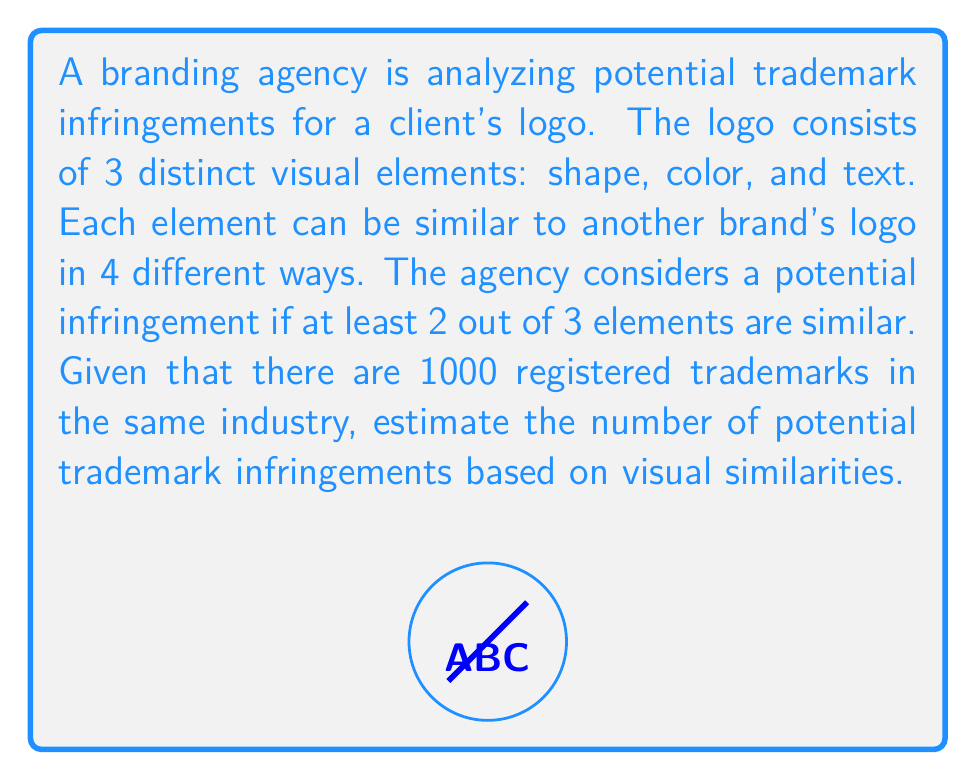Could you help me with this problem? Let's approach this step-by-step:

1) First, we need to calculate the probability of a single element being similar:
   For each element, there are 4 ways it can be similar out of 4 possible ways.
   Probability of similarity for one element = $\frac{4}{4} = 1$

2) Now, we need to calculate the probability of at least 2 out of 3 elements being similar:
   - Probability of all 3 elements being similar: $1 \times 1 \times 1 = 1$
   - Probability of exactly 2 elements being similar: $\binom{3}{2} \times 1 \times 1 \times 0 = 0$
   - Total probability: $1 + 0 = 1$

3) The probability of a potential infringement for one trademark is 1.

4) Given that there are 1000 registered trademarks, we can estimate the number of potential infringements:

   $$\text{Number of potential infringements} = 1000 \times 1 = 1000$$

Therefore, based on this analysis, we estimate that all 1000 registered trademarks could potentially be infringing on the client's logo.
Answer: 1000 